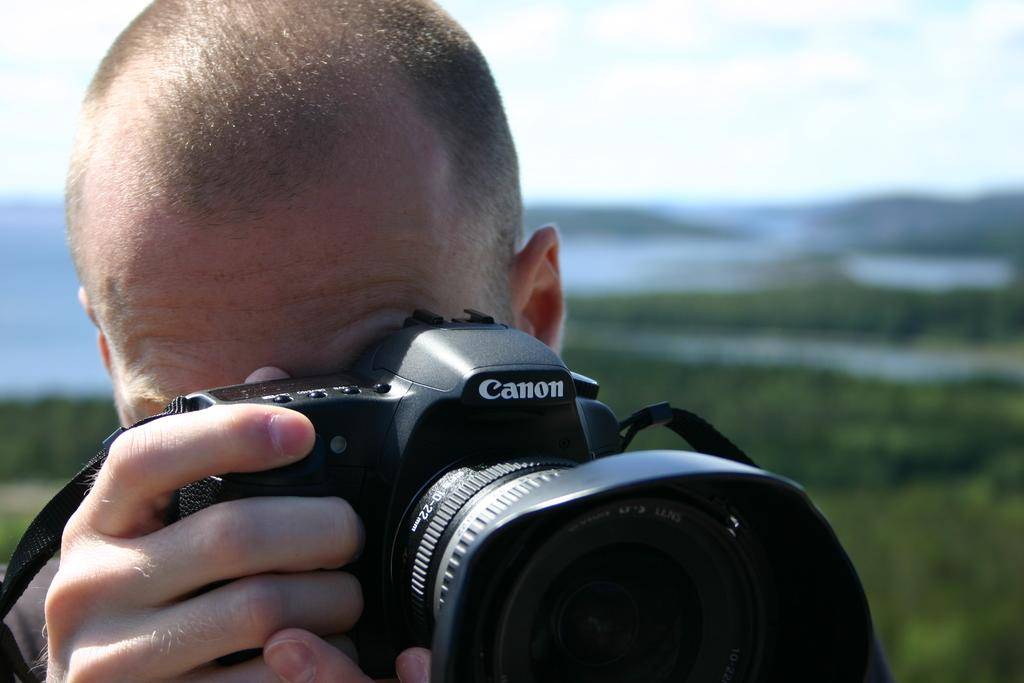What is the appearance of the person in the image? There is a guy with a bald head in the image. What is the guy holding in the image? The guy is holding a Canon Black camera. What is the guy doing with the camera? The guy is clicking images. What can be seen in the background of the image? There is a river and small trees in the background of the image. How does the stranger wash the fifth camera in the image? There is no stranger or fifth camera present in the image. The guy with a bald head is holding a Canon Black camera, and there is no mention of any other cameras. 